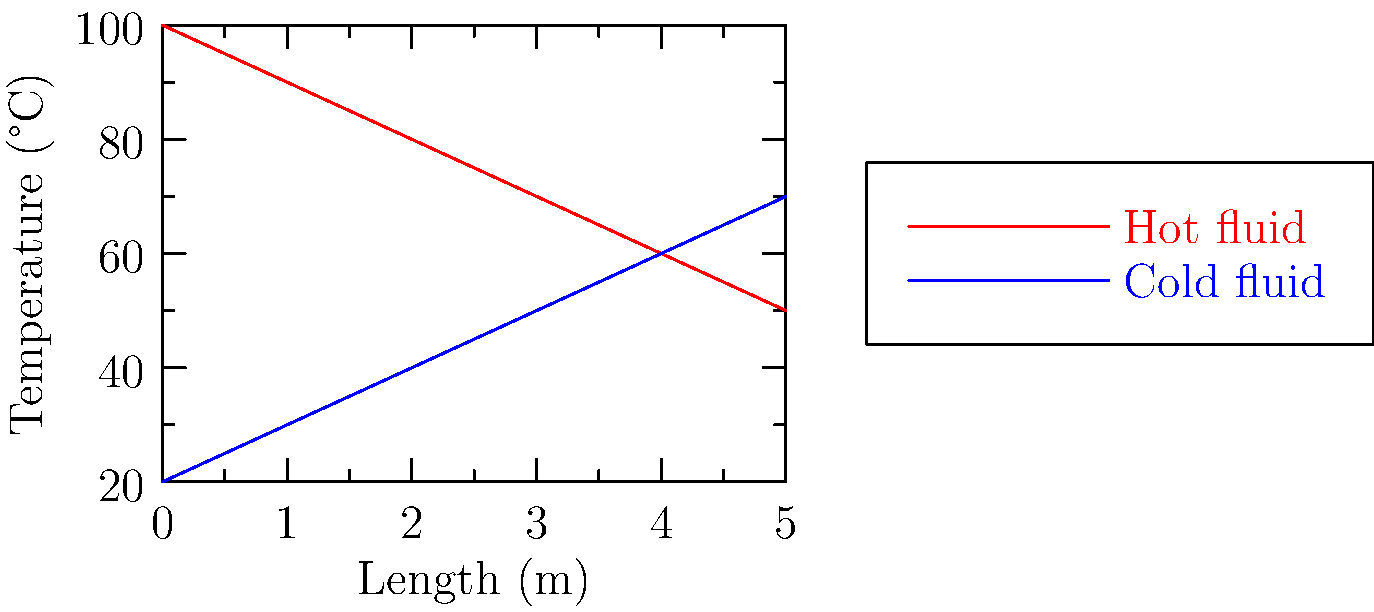What type of heat exchanger flow configuration does this temperature profile represent? 1. Observe the temperature trends:
   - Red line (hot fluid) decreases from left to right
   - Blue line (cold fluid) increases from left to right

2. Note that the temperature difference between fluids decreases along the length

3. Recognize that both fluids change temperature over the entire length

4. This pattern indicates that the fluids are flowing in opposite directions

5. In heat exchanger terminology, this configuration is called "counter-flow"

6. Counter-flow allows for the most efficient heat transfer between fluids
Answer: Counter-flow 